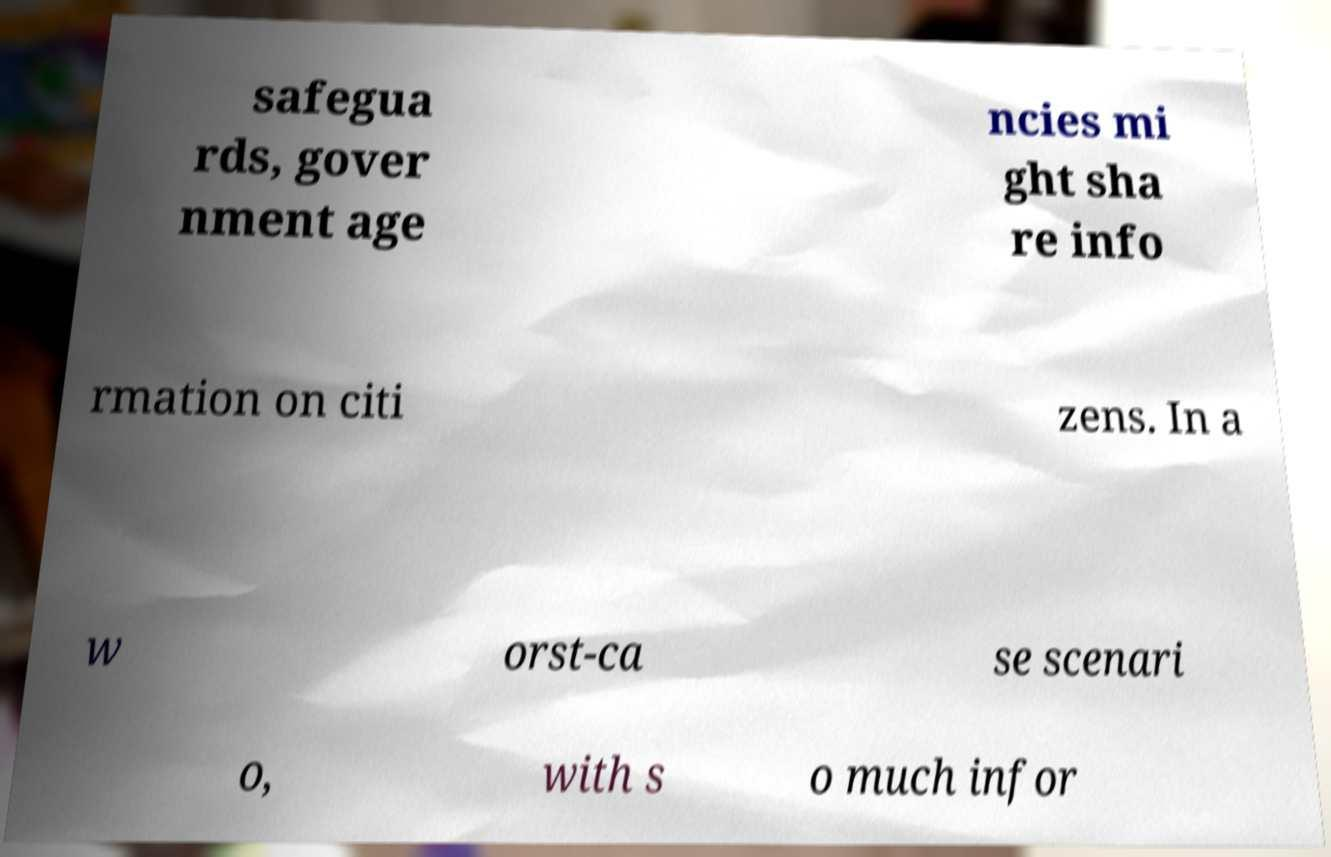There's text embedded in this image that I need extracted. Can you transcribe it verbatim? safegua rds, gover nment age ncies mi ght sha re info rmation on citi zens. In a w orst-ca se scenari o, with s o much infor 